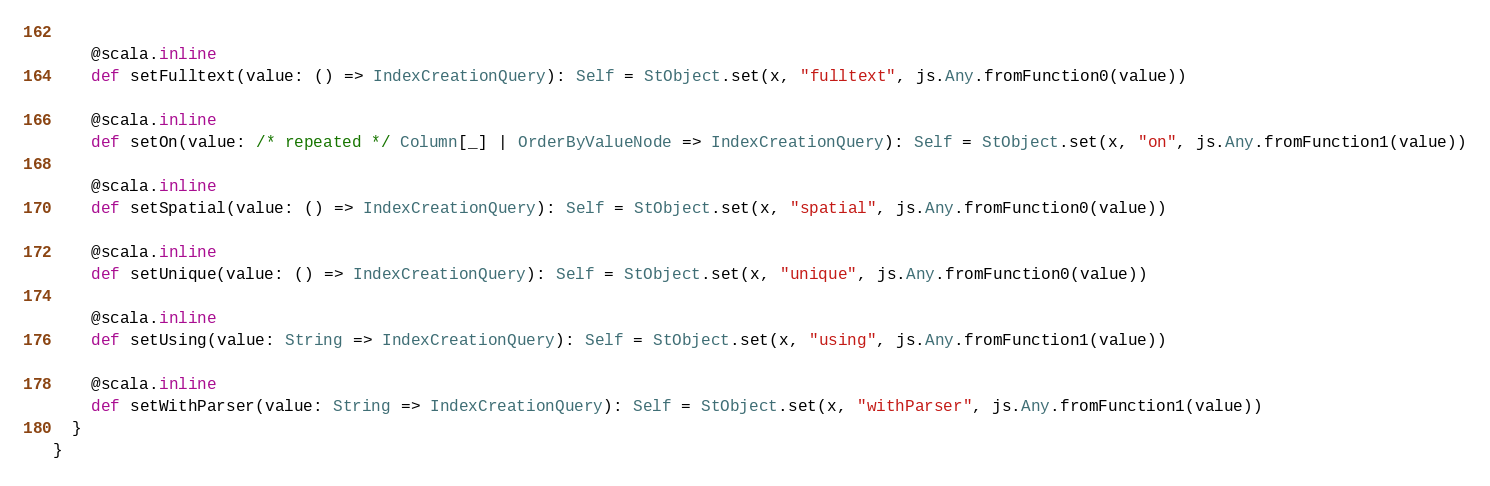Convert code to text. <code><loc_0><loc_0><loc_500><loc_500><_Scala_>    
    @scala.inline
    def setFulltext(value: () => IndexCreationQuery): Self = StObject.set(x, "fulltext", js.Any.fromFunction0(value))
    
    @scala.inline
    def setOn(value: /* repeated */ Column[_] | OrderByValueNode => IndexCreationQuery): Self = StObject.set(x, "on", js.Any.fromFunction1(value))
    
    @scala.inline
    def setSpatial(value: () => IndexCreationQuery): Self = StObject.set(x, "spatial", js.Any.fromFunction0(value))
    
    @scala.inline
    def setUnique(value: () => IndexCreationQuery): Self = StObject.set(x, "unique", js.Any.fromFunction0(value))
    
    @scala.inline
    def setUsing(value: String => IndexCreationQuery): Self = StObject.set(x, "using", js.Any.fromFunction1(value))
    
    @scala.inline
    def setWithParser(value: String => IndexCreationQuery): Self = StObject.set(x, "withParser", js.Any.fromFunction1(value))
  }
}
</code> 